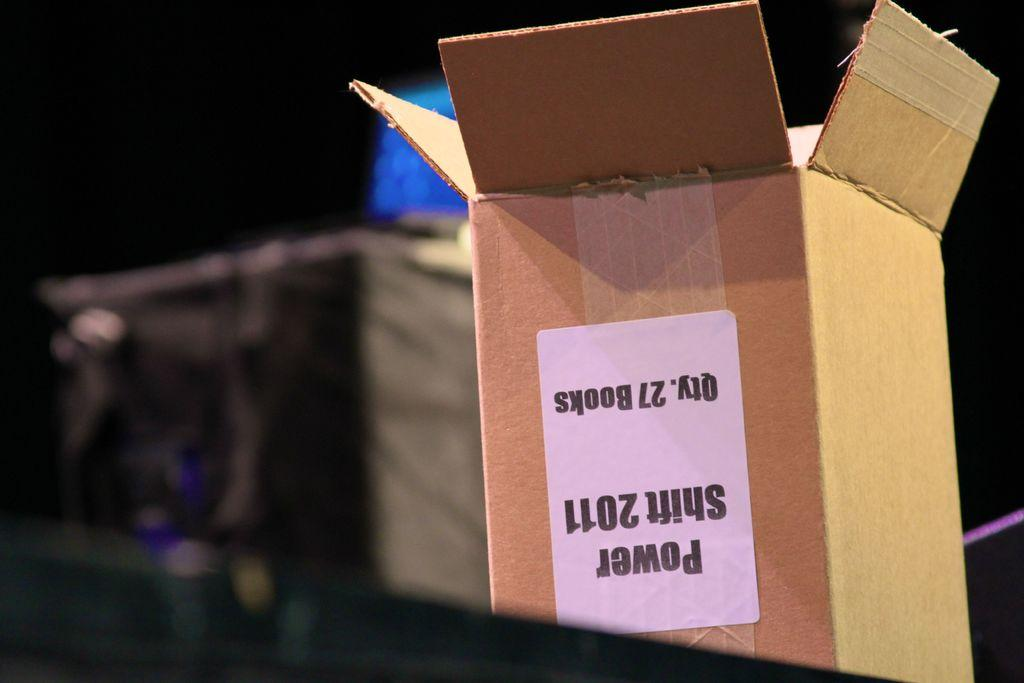<image>
Share a concise interpretation of the image provided. the word power is on a brown box in a room 